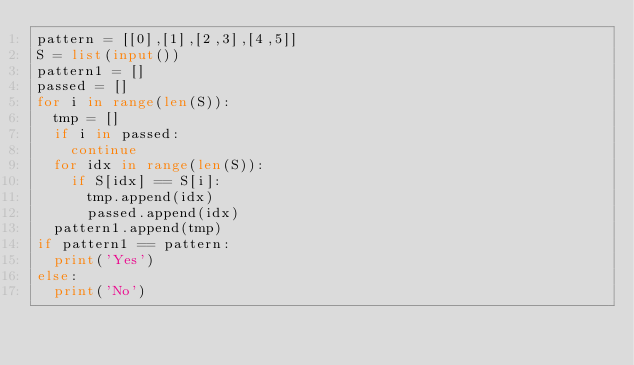<code> <loc_0><loc_0><loc_500><loc_500><_Python_>pattern = [[0],[1],[2,3],[4,5]]
S = list(input())
pattern1 = []
passed = []
for i in range(len(S)):
  tmp = []
  if i in passed:
    continue
  for idx in range(len(S)):
    if S[idx] == S[i]:
      tmp.append(idx)
      passed.append(idx)
  pattern1.append(tmp)
if pattern1 == pattern:
  print('Yes')
else:
  print('No')</code> 